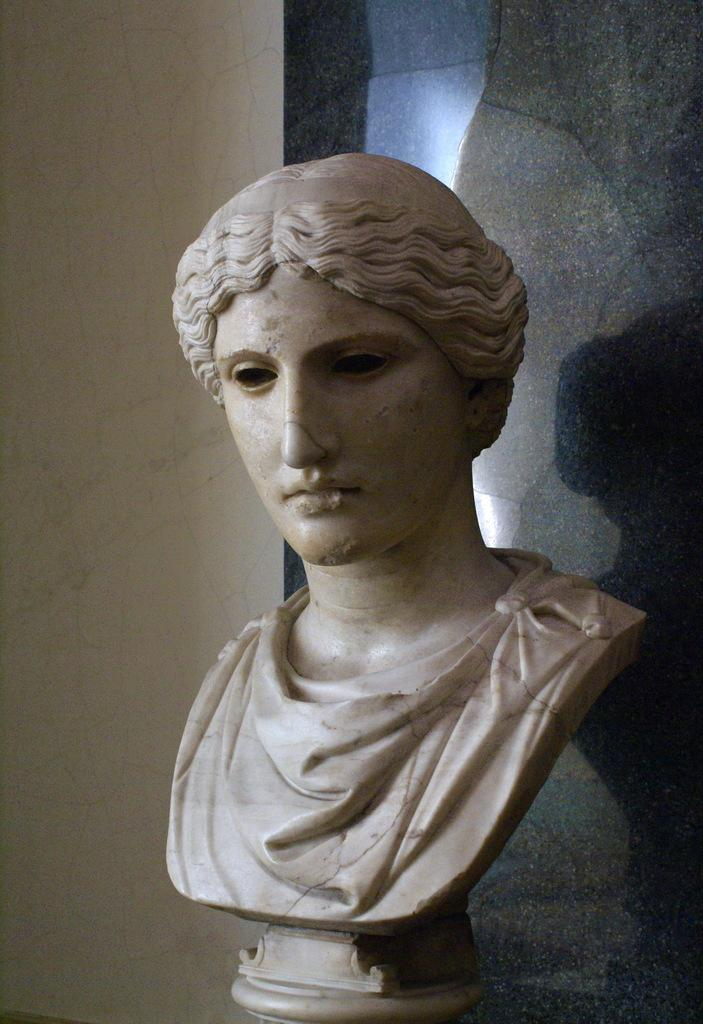What is the main subject of the image? There is a sculpture in the image. What is the sculpture's subject matter? The sculpture is of a person's face. Where is the sculpture located in the image? The sculpture is on a table. What type of doctor is examining the sculpture in the image? There is no doctor present in the image; it only features a sculpture of a person's face on a table. 